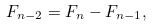Convert formula to latex. <formula><loc_0><loc_0><loc_500><loc_500>F _ { n - 2 } = F _ { n } - F _ { n - 1 } ,</formula> 